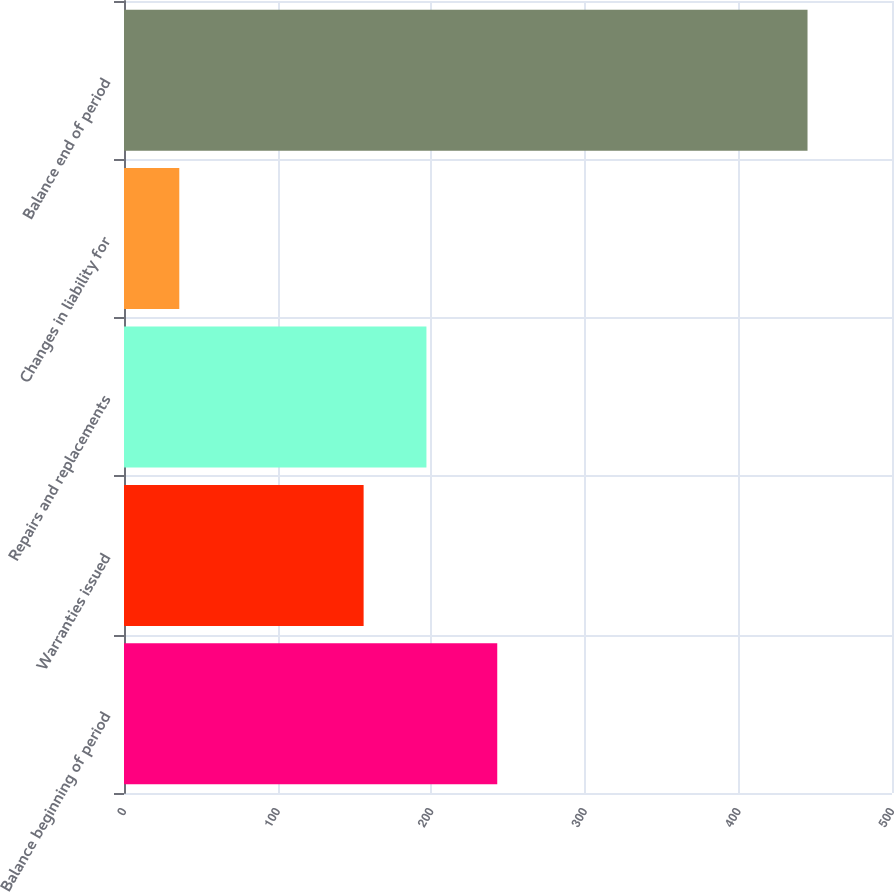Convert chart. <chart><loc_0><loc_0><loc_500><loc_500><bar_chart><fcel>Balance beginning of period<fcel>Warranties issued<fcel>Repairs and replacements<fcel>Changes in liability for<fcel>Balance end of period<nl><fcel>243<fcel>156<fcel>196.9<fcel>36<fcel>445<nl></chart> 